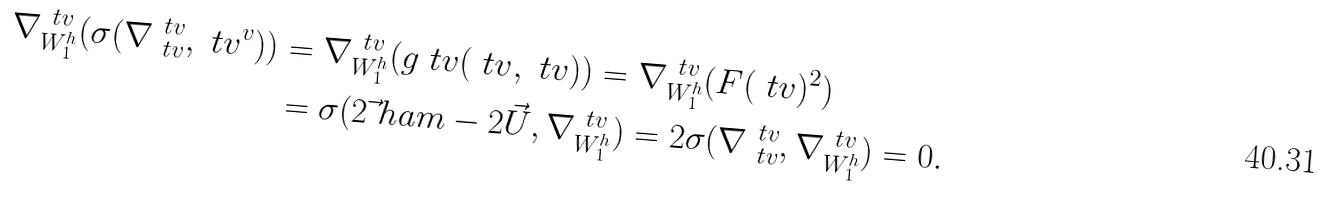Convert formula to latex. <formula><loc_0><loc_0><loc_500><loc_500>\nabla ^ { \ t v } _ { W _ { 1 } ^ { h } } ( \sigma ( \nabla _ { \ t v } ^ { \ t v } , \ t v ^ { v } ) ) & = \nabla ^ { \ t v } _ { W _ { 1 } ^ { h } } ( g _ { \ } t v ( \ t v , \ t v ) ) = \nabla ^ { \ t v } _ { W _ { 1 } ^ { h } } ( F ( \ t v ) ^ { 2 } ) \\ & = \sigma ( 2 \vec { \ } h a m - 2 \vec { U } , \nabla ^ { \ t v } _ { W _ { 1 } ^ { h } } ) = 2 \sigma ( \nabla ^ { \ t v } _ { \ t v } , \nabla ^ { \ t v } _ { W _ { 1 } ^ { h } } ) = 0 .</formula> 